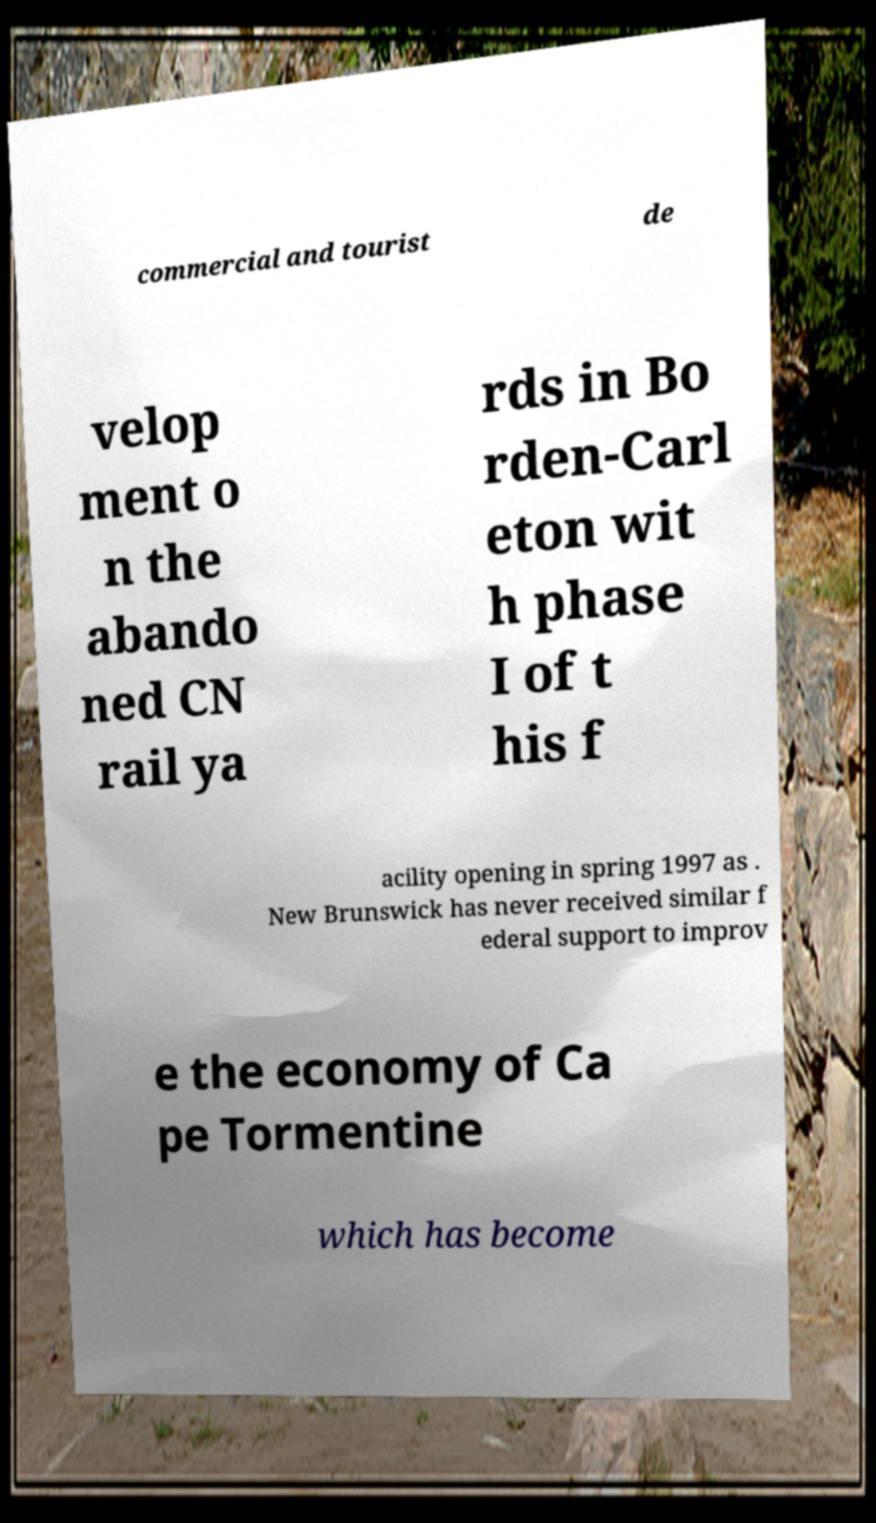Can you read and provide the text displayed in the image?This photo seems to have some interesting text. Can you extract and type it out for me? commercial and tourist de velop ment o n the abando ned CN rail ya rds in Bo rden-Carl eton wit h phase I of t his f acility opening in spring 1997 as . New Brunswick has never received similar f ederal support to improv e the economy of Ca pe Tormentine which has become 